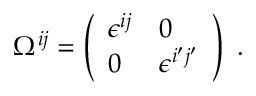<formula> <loc_0><loc_0><loc_500><loc_500>\Omega ^ { i j } = \left ( \begin{array} { l l } { { \epsilon ^ { i j } } } & { 0 } \\ { 0 } & { { \epsilon ^ { i ^ { \prime } j ^ { \prime } } } } \end{array} \right ) \ .</formula> 